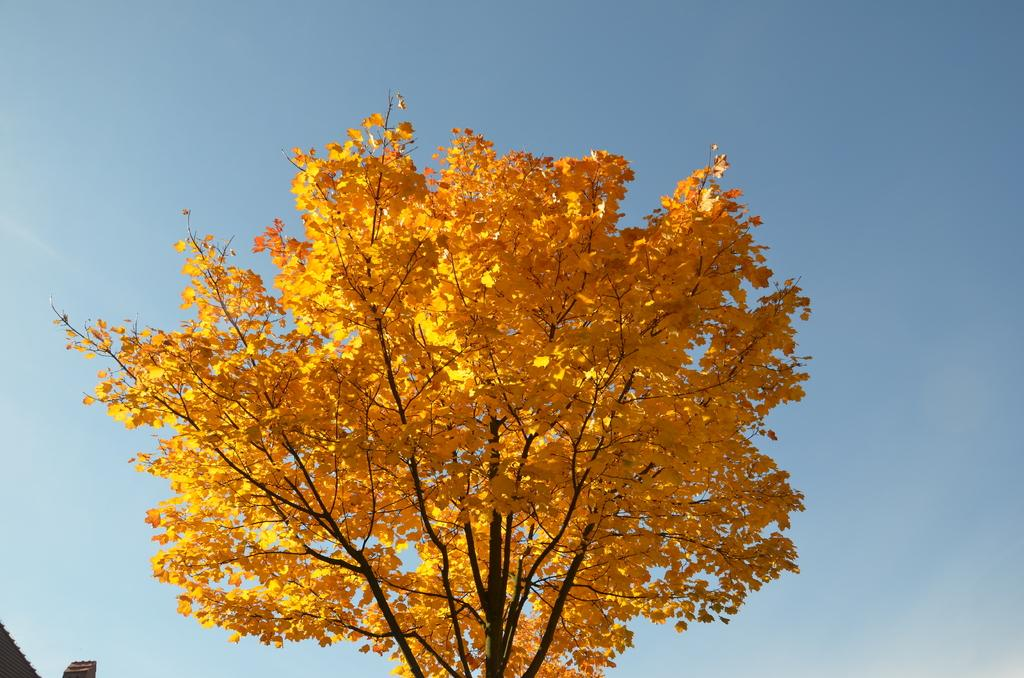What can be seen in the background of the image? The sky is visible in the background of the image. What type of vegetation is present in the image? There is a tree in the image. What color are the leaves on the tree? The tree has yellow leaves. What is the manager discussing with the dog in the image? There is no manager or dog present in the image; it features a tree with yellow leaves and a visible sky in the background. 